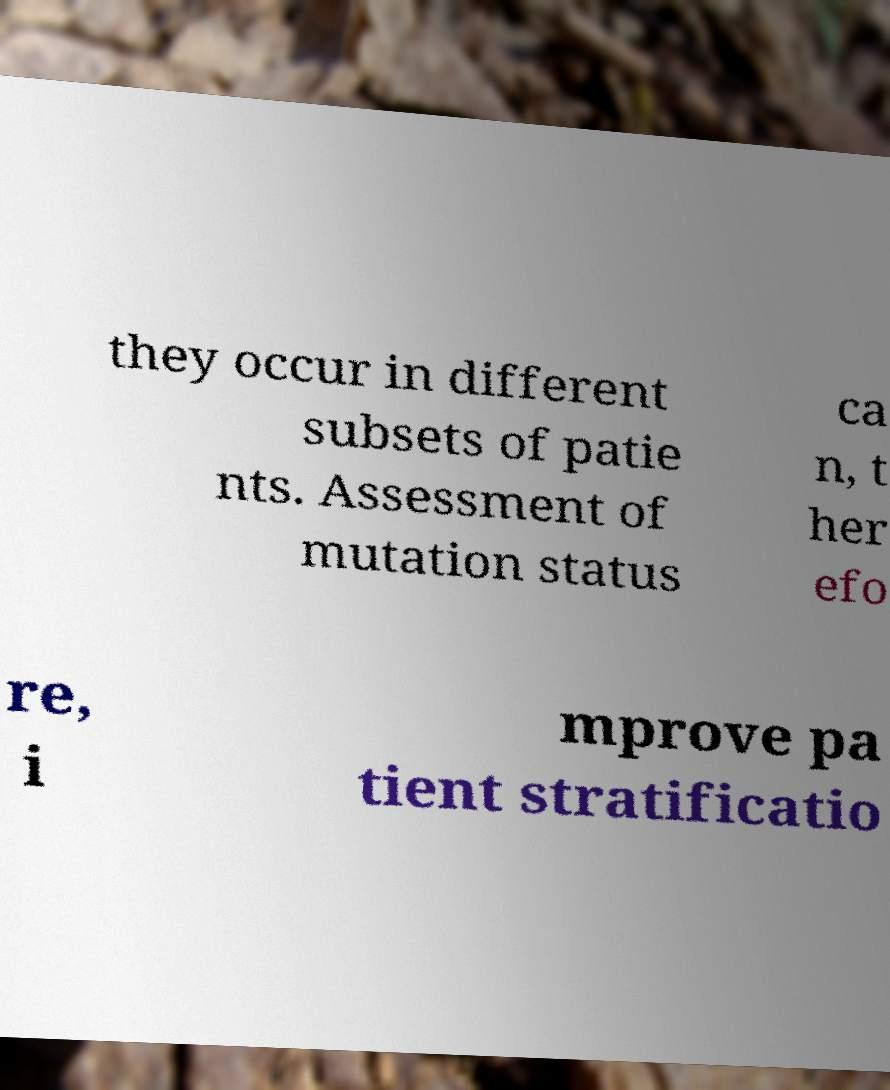Could you assist in decoding the text presented in this image and type it out clearly? they occur in different subsets of patie nts. Assessment of mutation status ca n, t her efo re, i mprove pa tient stratificatio 